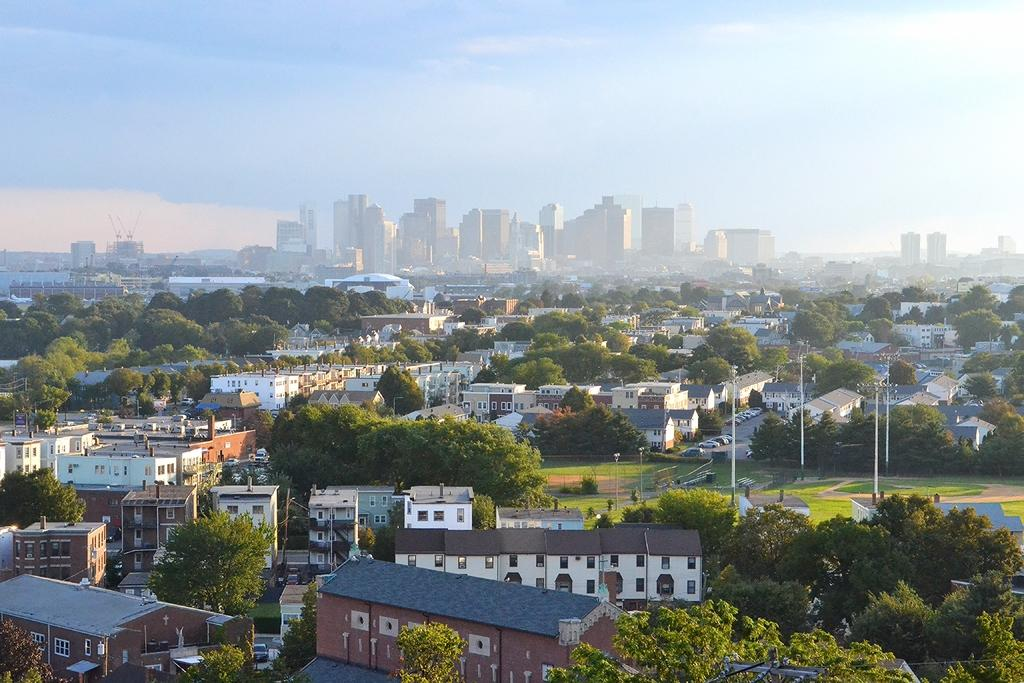What type of structures can be seen in the image? There are houses, trees, poles, vehicles parked on the road, and buildings visible in the image. What is the natural element present in the image? There are trees in the image. What can be seen on the road in the image? There are vehicles parked on the road in the image. What is visible at the top of the image? The sky is visible in the image. Where is the fireman eating lunch in the image? There is no fireman or lunchroom present in the image. What type of nerve can be seen in the image? There is no nerve visible in the image. 